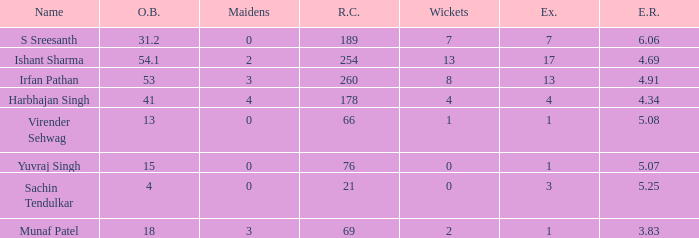Name the runs conceded where overs bowled is 53 1.0. 